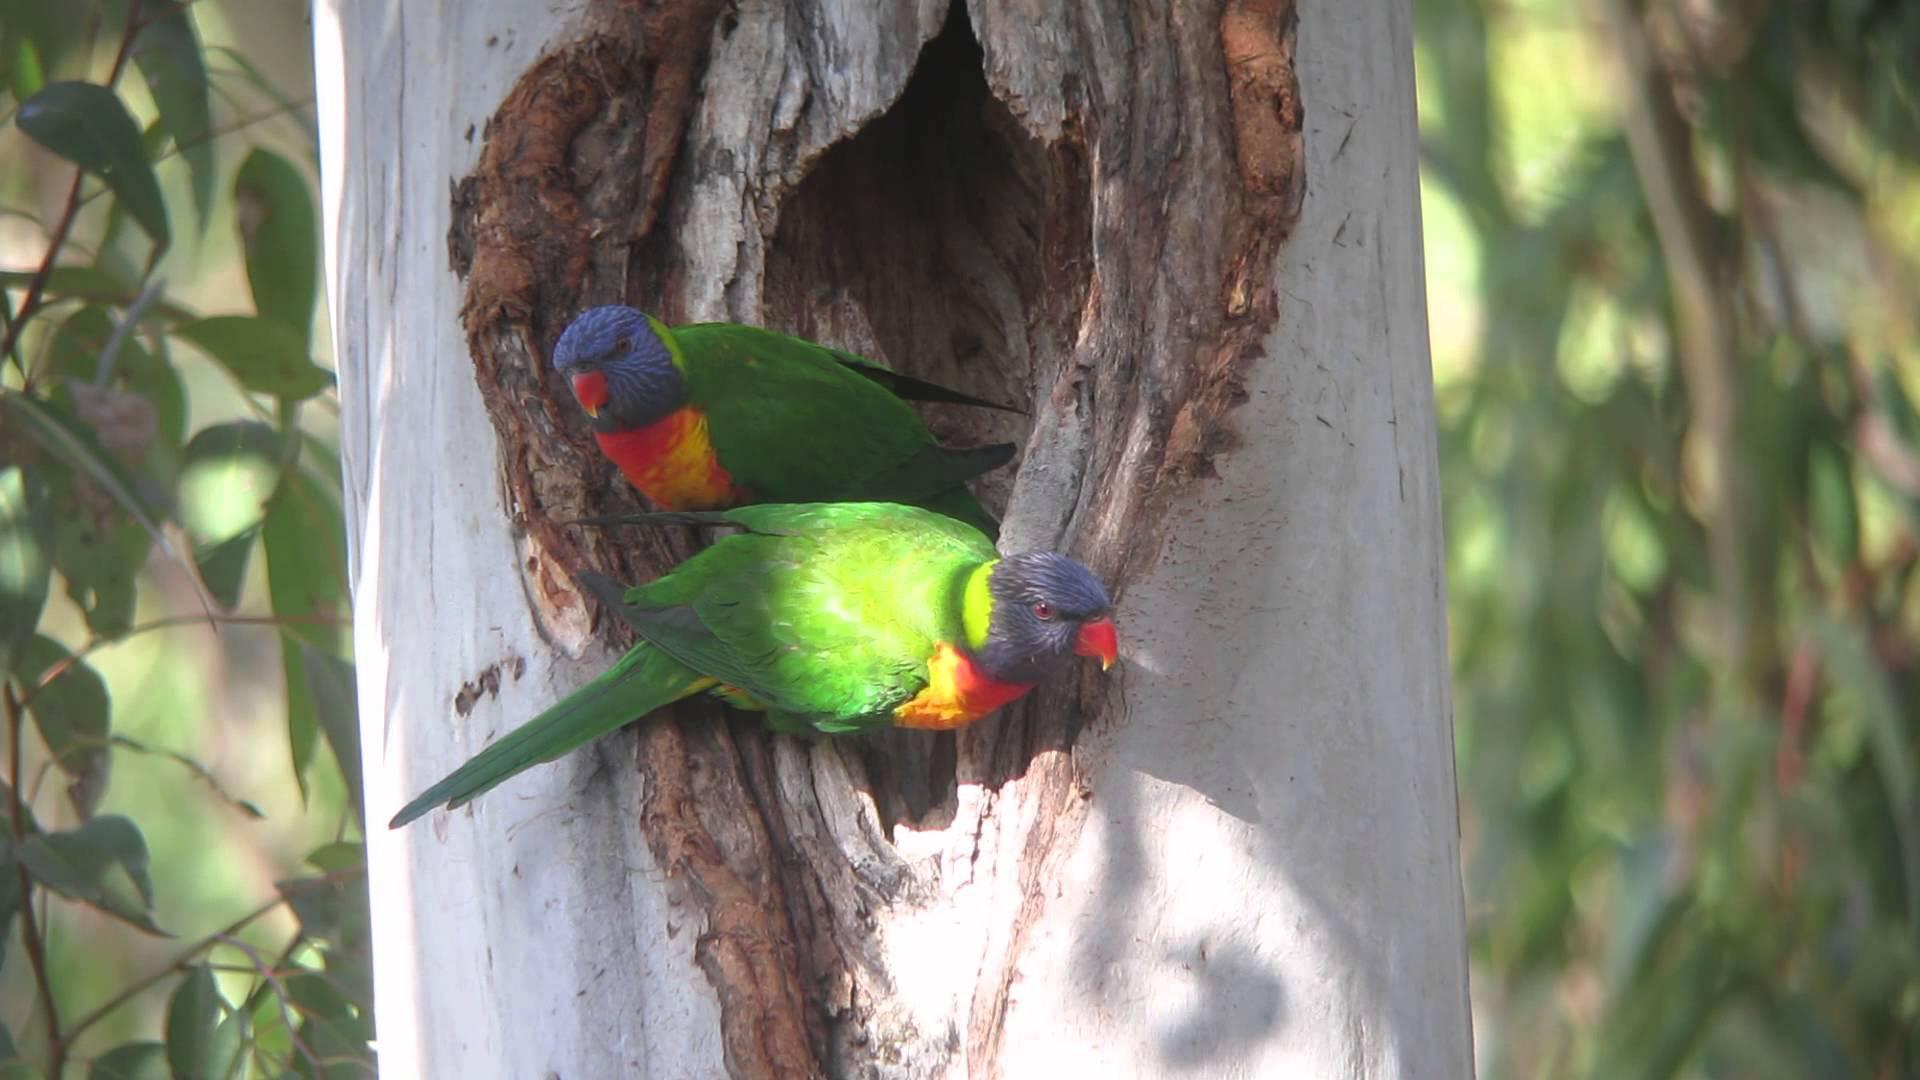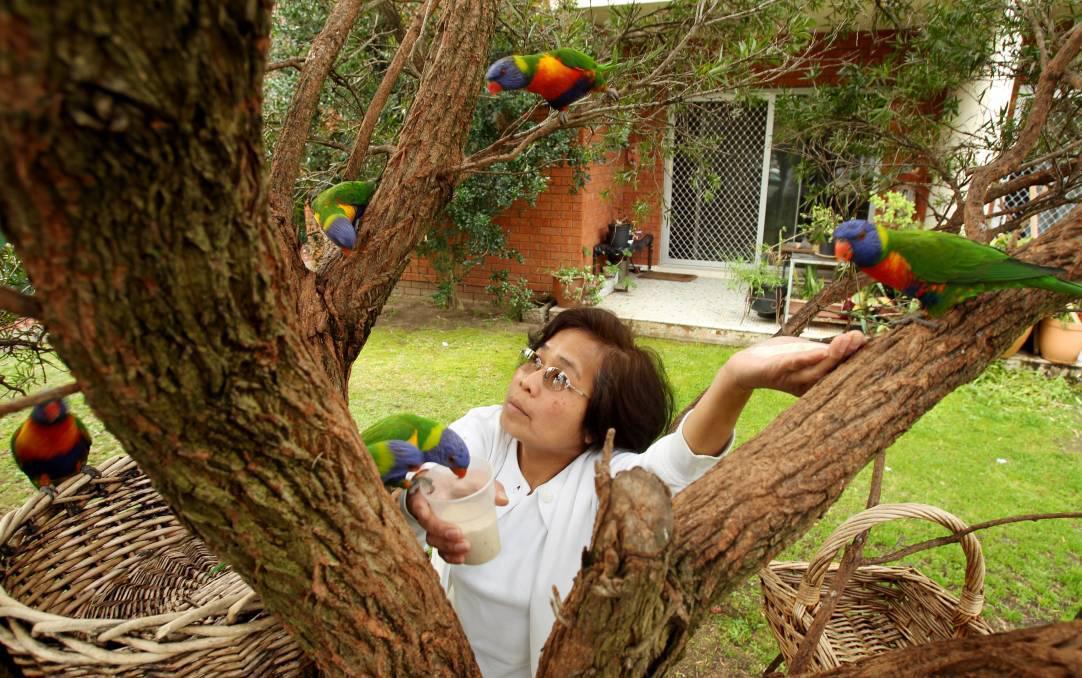The first image is the image on the left, the second image is the image on the right. For the images displayed, is the sentence "Left and right images each show no more than two birds, and all images show a bird near a hollow in a tree." factually correct? Answer yes or no. No. The first image is the image on the left, the second image is the image on the right. Evaluate the accuracy of this statement regarding the images: "The right image contains at least three parrots.". Is it true? Answer yes or no. Yes. 